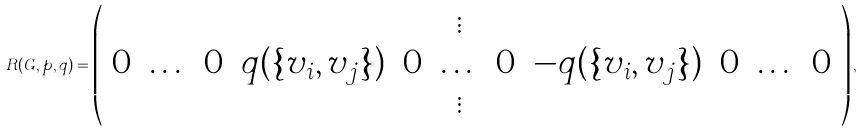<formula> <loc_0><loc_0><loc_500><loc_500>R ( G , p , q ) = \left ( \begin{array} { c c c c c c c c c c c } & & & & & \vdots & & & & & \\ 0 & \dots & 0 & q ( \{ v _ { i } , v _ { j } \} ) & 0 & \dots & 0 & - q ( \{ v _ { i } , v _ { j } \} ) & 0 & \dots & 0 \\ & & & & & \vdots & & & & & \end{array} \right ) ,</formula> 